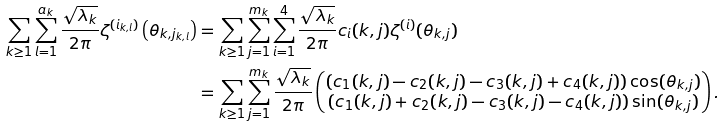<formula> <loc_0><loc_0><loc_500><loc_500>\sum _ { k \geq 1 } \sum _ { l = 1 } ^ { a _ { k } } \frac { \sqrt { \lambda _ { k } } } { 2 \pi } \zeta ^ { ( i _ { k , l } ) } \left ( \theta _ { k , j _ { k , l } } \right ) & = \sum _ { k \geq 1 } \sum _ { j = 1 } ^ { m _ { k } } \sum _ { i = 1 } ^ { 4 } \frac { \sqrt { \lambda _ { k } } } { 2 \pi } c _ { i } ( k , j ) \zeta ^ { ( i ) } ( \theta _ { k , j } ) \\ & = \sum _ { k \geq 1 } \sum _ { j = 1 } ^ { m _ { k } } \frac { \sqrt { \lambda _ { k } } } { 2 \pi } \begin{pmatrix} \left ( c _ { 1 } ( k , j ) - c _ { 2 } ( k , j ) - c _ { 3 } ( k , j ) + c _ { 4 } ( k , j ) \right ) \cos ( \theta _ { k , j } ) \\ \left ( c _ { 1 } ( k , j ) + c _ { 2 } ( k , j ) - c _ { 3 } ( k , j ) - c _ { 4 } ( k , j ) \right ) \sin ( \theta _ { k , j } ) \end{pmatrix} .</formula> 